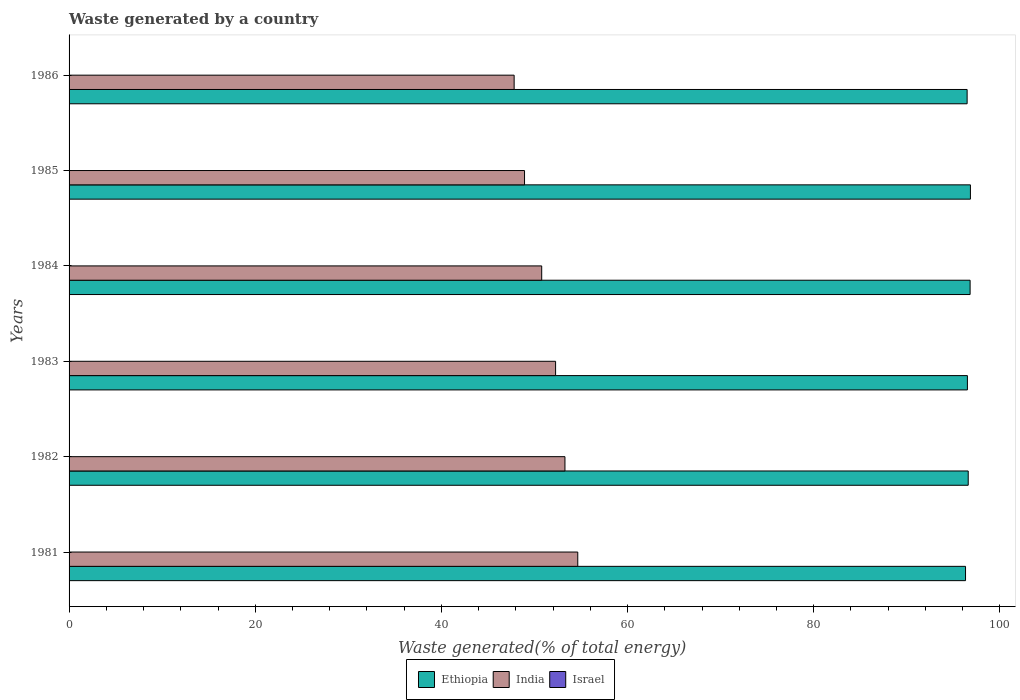How many different coloured bars are there?
Provide a short and direct response. 3. How many groups of bars are there?
Ensure brevity in your answer.  6. Are the number of bars per tick equal to the number of legend labels?
Your answer should be very brief. Yes. Are the number of bars on each tick of the Y-axis equal?
Provide a succinct answer. Yes. How many bars are there on the 5th tick from the bottom?
Your answer should be very brief. 3. What is the label of the 6th group of bars from the top?
Provide a short and direct response. 1981. What is the total waste generated in Israel in 1983?
Provide a succinct answer. 0.03. Across all years, what is the maximum total waste generated in Ethiopia?
Your answer should be compact. 96.84. Across all years, what is the minimum total waste generated in Ethiopia?
Make the answer very short. 96.31. What is the total total waste generated in Israel in the graph?
Your response must be concise. 0.2. What is the difference between the total waste generated in Ethiopia in 1984 and that in 1985?
Give a very brief answer. -0.03. What is the difference between the total waste generated in Ethiopia in 1981 and the total waste generated in Israel in 1983?
Make the answer very short. 96.27. What is the average total waste generated in Ethiopia per year?
Offer a terse response. 96.59. In the year 1983, what is the difference between the total waste generated in Ethiopia and total waste generated in India?
Provide a succinct answer. 44.24. In how many years, is the total waste generated in Ethiopia greater than 52 %?
Keep it short and to the point. 6. What is the ratio of the total waste generated in India in 1984 to that in 1985?
Your answer should be compact. 1.04. Is the difference between the total waste generated in Ethiopia in 1981 and 1983 greater than the difference between the total waste generated in India in 1981 and 1983?
Your answer should be very brief. No. What is the difference between the highest and the second highest total waste generated in Israel?
Your answer should be compact. 0. What is the difference between the highest and the lowest total waste generated in Ethiopia?
Give a very brief answer. 0.53. In how many years, is the total waste generated in India greater than the average total waste generated in India taken over all years?
Keep it short and to the point. 3. Is the sum of the total waste generated in India in 1981 and 1983 greater than the maximum total waste generated in Israel across all years?
Keep it short and to the point. Yes. What does the 1st bar from the bottom in 1986 represents?
Your answer should be very brief. Ethiopia. How many bars are there?
Provide a succinct answer. 18. What is the difference between two consecutive major ticks on the X-axis?
Offer a very short reply. 20. Are the values on the major ticks of X-axis written in scientific E-notation?
Give a very brief answer. No. Does the graph contain any zero values?
Your answer should be very brief. No. How are the legend labels stacked?
Ensure brevity in your answer.  Horizontal. What is the title of the graph?
Provide a succinct answer. Waste generated by a country. What is the label or title of the X-axis?
Ensure brevity in your answer.  Waste generated(% of total energy). What is the label or title of the Y-axis?
Provide a short and direct response. Years. What is the Waste generated(% of total energy) in Ethiopia in 1981?
Offer a very short reply. 96.31. What is the Waste generated(% of total energy) in India in 1981?
Your response must be concise. 54.65. What is the Waste generated(% of total energy) in Israel in 1981?
Offer a very short reply. 0.04. What is the Waste generated(% of total energy) of Ethiopia in 1982?
Give a very brief answer. 96.6. What is the Waste generated(% of total energy) in India in 1982?
Your response must be concise. 53.27. What is the Waste generated(% of total energy) in Israel in 1982?
Keep it short and to the point. 0.03. What is the Waste generated(% of total energy) in Ethiopia in 1983?
Provide a succinct answer. 96.51. What is the Waste generated(% of total energy) of India in 1983?
Your answer should be very brief. 52.27. What is the Waste generated(% of total energy) in Israel in 1983?
Your answer should be compact. 0.03. What is the Waste generated(% of total energy) in Ethiopia in 1984?
Provide a short and direct response. 96.8. What is the Waste generated(% of total energy) of India in 1984?
Give a very brief answer. 50.78. What is the Waste generated(% of total energy) of Israel in 1984?
Offer a very short reply. 0.03. What is the Waste generated(% of total energy) of Ethiopia in 1985?
Offer a very short reply. 96.84. What is the Waste generated(% of total energy) in India in 1985?
Offer a terse response. 48.93. What is the Waste generated(% of total energy) of Israel in 1985?
Offer a terse response. 0.03. What is the Waste generated(% of total energy) in Ethiopia in 1986?
Give a very brief answer. 96.48. What is the Waste generated(% of total energy) of India in 1986?
Offer a terse response. 47.82. What is the Waste generated(% of total energy) in Israel in 1986?
Your answer should be very brief. 0.03. Across all years, what is the maximum Waste generated(% of total energy) in Ethiopia?
Keep it short and to the point. 96.84. Across all years, what is the maximum Waste generated(% of total energy) of India?
Provide a succinct answer. 54.65. Across all years, what is the maximum Waste generated(% of total energy) in Israel?
Offer a terse response. 0.04. Across all years, what is the minimum Waste generated(% of total energy) of Ethiopia?
Make the answer very short. 96.31. Across all years, what is the minimum Waste generated(% of total energy) of India?
Your answer should be compact. 47.82. Across all years, what is the minimum Waste generated(% of total energy) in Israel?
Keep it short and to the point. 0.03. What is the total Waste generated(% of total energy) in Ethiopia in the graph?
Keep it short and to the point. 579.54. What is the total Waste generated(% of total energy) in India in the graph?
Ensure brevity in your answer.  307.72. What is the total Waste generated(% of total energy) in Israel in the graph?
Your answer should be compact. 0.2. What is the difference between the Waste generated(% of total energy) of Ethiopia in 1981 and that in 1982?
Make the answer very short. -0.29. What is the difference between the Waste generated(% of total energy) of India in 1981 and that in 1982?
Keep it short and to the point. 1.38. What is the difference between the Waste generated(% of total energy) in Israel in 1981 and that in 1982?
Make the answer very short. 0. What is the difference between the Waste generated(% of total energy) of Ethiopia in 1981 and that in 1983?
Make the answer very short. -0.2. What is the difference between the Waste generated(% of total energy) in India in 1981 and that in 1983?
Offer a terse response. 2.38. What is the difference between the Waste generated(% of total energy) in Ethiopia in 1981 and that in 1984?
Ensure brevity in your answer.  -0.49. What is the difference between the Waste generated(% of total energy) of India in 1981 and that in 1984?
Offer a terse response. 3.87. What is the difference between the Waste generated(% of total energy) of Israel in 1981 and that in 1984?
Your answer should be compact. 0. What is the difference between the Waste generated(% of total energy) of Ethiopia in 1981 and that in 1985?
Your response must be concise. -0.53. What is the difference between the Waste generated(% of total energy) of India in 1981 and that in 1985?
Provide a short and direct response. 5.72. What is the difference between the Waste generated(% of total energy) in Israel in 1981 and that in 1985?
Provide a short and direct response. 0. What is the difference between the Waste generated(% of total energy) of Ethiopia in 1981 and that in 1986?
Give a very brief answer. -0.17. What is the difference between the Waste generated(% of total energy) in India in 1981 and that in 1986?
Ensure brevity in your answer.  6.83. What is the difference between the Waste generated(% of total energy) in Israel in 1981 and that in 1986?
Offer a very short reply. 0.01. What is the difference between the Waste generated(% of total energy) in Ethiopia in 1982 and that in 1983?
Offer a very short reply. 0.09. What is the difference between the Waste generated(% of total energy) of India in 1982 and that in 1983?
Provide a short and direct response. 1.01. What is the difference between the Waste generated(% of total energy) of Israel in 1982 and that in 1983?
Your answer should be compact. -0. What is the difference between the Waste generated(% of total energy) in Ethiopia in 1982 and that in 1984?
Offer a terse response. -0.2. What is the difference between the Waste generated(% of total energy) in India in 1982 and that in 1984?
Your response must be concise. 2.5. What is the difference between the Waste generated(% of total energy) of Israel in 1982 and that in 1984?
Offer a very short reply. -0. What is the difference between the Waste generated(% of total energy) in Ethiopia in 1982 and that in 1985?
Make the answer very short. -0.24. What is the difference between the Waste generated(% of total energy) of India in 1982 and that in 1985?
Give a very brief answer. 4.34. What is the difference between the Waste generated(% of total energy) in Israel in 1982 and that in 1985?
Ensure brevity in your answer.  -0. What is the difference between the Waste generated(% of total energy) of Ethiopia in 1982 and that in 1986?
Make the answer very short. 0.12. What is the difference between the Waste generated(% of total energy) of India in 1982 and that in 1986?
Your answer should be very brief. 5.46. What is the difference between the Waste generated(% of total energy) of Israel in 1982 and that in 1986?
Your answer should be very brief. 0. What is the difference between the Waste generated(% of total energy) in Ethiopia in 1983 and that in 1984?
Keep it short and to the point. -0.29. What is the difference between the Waste generated(% of total energy) in India in 1983 and that in 1984?
Your response must be concise. 1.49. What is the difference between the Waste generated(% of total energy) of Israel in 1983 and that in 1984?
Offer a very short reply. 0. What is the difference between the Waste generated(% of total energy) of Ethiopia in 1983 and that in 1985?
Offer a terse response. -0.32. What is the difference between the Waste generated(% of total energy) in India in 1983 and that in 1985?
Provide a short and direct response. 3.34. What is the difference between the Waste generated(% of total energy) in Israel in 1983 and that in 1985?
Keep it short and to the point. 0. What is the difference between the Waste generated(% of total energy) of Ethiopia in 1983 and that in 1986?
Give a very brief answer. 0.03. What is the difference between the Waste generated(% of total energy) in India in 1983 and that in 1986?
Make the answer very short. 4.45. What is the difference between the Waste generated(% of total energy) of Israel in 1983 and that in 1986?
Offer a very short reply. 0.01. What is the difference between the Waste generated(% of total energy) of Ethiopia in 1984 and that in 1985?
Provide a short and direct response. -0.03. What is the difference between the Waste generated(% of total energy) in India in 1984 and that in 1985?
Give a very brief answer. 1.85. What is the difference between the Waste generated(% of total energy) in Israel in 1984 and that in 1985?
Keep it short and to the point. -0. What is the difference between the Waste generated(% of total energy) in Ethiopia in 1984 and that in 1986?
Keep it short and to the point. 0.32. What is the difference between the Waste generated(% of total energy) of India in 1984 and that in 1986?
Provide a short and direct response. 2.96. What is the difference between the Waste generated(% of total energy) of Israel in 1984 and that in 1986?
Provide a succinct answer. 0.01. What is the difference between the Waste generated(% of total energy) in Ethiopia in 1985 and that in 1986?
Offer a terse response. 0.35. What is the difference between the Waste generated(% of total energy) of India in 1985 and that in 1986?
Offer a terse response. 1.12. What is the difference between the Waste generated(% of total energy) of Israel in 1985 and that in 1986?
Your response must be concise. 0.01. What is the difference between the Waste generated(% of total energy) of Ethiopia in 1981 and the Waste generated(% of total energy) of India in 1982?
Your answer should be compact. 43.03. What is the difference between the Waste generated(% of total energy) of Ethiopia in 1981 and the Waste generated(% of total energy) of Israel in 1982?
Ensure brevity in your answer.  96.28. What is the difference between the Waste generated(% of total energy) in India in 1981 and the Waste generated(% of total energy) in Israel in 1982?
Offer a very short reply. 54.62. What is the difference between the Waste generated(% of total energy) in Ethiopia in 1981 and the Waste generated(% of total energy) in India in 1983?
Your answer should be compact. 44.04. What is the difference between the Waste generated(% of total energy) of Ethiopia in 1981 and the Waste generated(% of total energy) of Israel in 1983?
Give a very brief answer. 96.27. What is the difference between the Waste generated(% of total energy) in India in 1981 and the Waste generated(% of total energy) in Israel in 1983?
Give a very brief answer. 54.62. What is the difference between the Waste generated(% of total energy) in Ethiopia in 1981 and the Waste generated(% of total energy) in India in 1984?
Provide a short and direct response. 45.53. What is the difference between the Waste generated(% of total energy) in Ethiopia in 1981 and the Waste generated(% of total energy) in Israel in 1984?
Keep it short and to the point. 96.28. What is the difference between the Waste generated(% of total energy) of India in 1981 and the Waste generated(% of total energy) of Israel in 1984?
Provide a succinct answer. 54.62. What is the difference between the Waste generated(% of total energy) in Ethiopia in 1981 and the Waste generated(% of total energy) in India in 1985?
Make the answer very short. 47.38. What is the difference between the Waste generated(% of total energy) of Ethiopia in 1981 and the Waste generated(% of total energy) of Israel in 1985?
Provide a succinct answer. 96.28. What is the difference between the Waste generated(% of total energy) of India in 1981 and the Waste generated(% of total energy) of Israel in 1985?
Provide a succinct answer. 54.62. What is the difference between the Waste generated(% of total energy) in Ethiopia in 1981 and the Waste generated(% of total energy) in India in 1986?
Ensure brevity in your answer.  48.49. What is the difference between the Waste generated(% of total energy) in Ethiopia in 1981 and the Waste generated(% of total energy) in Israel in 1986?
Keep it short and to the point. 96.28. What is the difference between the Waste generated(% of total energy) in India in 1981 and the Waste generated(% of total energy) in Israel in 1986?
Your answer should be very brief. 54.62. What is the difference between the Waste generated(% of total energy) of Ethiopia in 1982 and the Waste generated(% of total energy) of India in 1983?
Make the answer very short. 44.33. What is the difference between the Waste generated(% of total energy) in Ethiopia in 1982 and the Waste generated(% of total energy) in Israel in 1983?
Offer a terse response. 96.56. What is the difference between the Waste generated(% of total energy) in India in 1982 and the Waste generated(% of total energy) in Israel in 1983?
Your answer should be very brief. 53.24. What is the difference between the Waste generated(% of total energy) of Ethiopia in 1982 and the Waste generated(% of total energy) of India in 1984?
Offer a very short reply. 45.82. What is the difference between the Waste generated(% of total energy) in Ethiopia in 1982 and the Waste generated(% of total energy) in Israel in 1984?
Your answer should be compact. 96.56. What is the difference between the Waste generated(% of total energy) of India in 1982 and the Waste generated(% of total energy) of Israel in 1984?
Your answer should be very brief. 53.24. What is the difference between the Waste generated(% of total energy) in Ethiopia in 1982 and the Waste generated(% of total energy) in India in 1985?
Offer a terse response. 47.67. What is the difference between the Waste generated(% of total energy) in Ethiopia in 1982 and the Waste generated(% of total energy) in Israel in 1985?
Offer a terse response. 96.56. What is the difference between the Waste generated(% of total energy) of India in 1982 and the Waste generated(% of total energy) of Israel in 1985?
Make the answer very short. 53.24. What is the difference between the Waste generated(% of total energy) of Ethiopia in 1982 and the Waste generated(% of total energy) of India in 1986?
Your response must be concise. 48.78. What is the difference between the Waste generated(% of total energy) in Ethiopia in 1982 and the Waste generated(% of total energy) in Israel in 1986?
Offer a terse response. 96.57. What is the difference between the Waste generated(% of total energy) in India in 1982 and the Waste generated(% of total energy) in Israel in 1986?
Give a very brief answer. 53.25. What is the difference between the Waste generated(% of total energy) in Ethiopia in 1983 and the Waste generated(% of total energy) in India in 1984?
Keep it short and to the point. 45.74. What is the difference between the Waste generated(% of total energy) of Ethiopia in 1983 and the Waste generated(% of total energy) of Israel in 1984?
Your answer should be compact. 96.48. What is the difference between the Waste generated(% of total energy) in India in 1983 and the Waste generated(% of total energy) in Israel in 1984?
Ensure brevity in your answer.  52.24. What is the difference between the Waste generated(% of total energy) of Ethiopia in 1983 and the Waste generated(% of total energy) of India in 1985?
Make the answer very short. 47.58. What is the difference between the Waste generated(% of total energy) in Ethiopia in 1983 and the Waste generated(% of total energy) in Israel in 1985?
Ensure brevity in your answer.  96.48. What is the difference between the Waste generated(% of total energy) in India in 1983 and the Waste generated(% of total energy) in Israel in 1985?
Provide a succinct answer. 52.24. What is the difference between the Waste generated(% of total energy) in Ethiopia in 1983 and the Waste generated(% of total energy) in India in 1986?
Offer a very short reply. 48.7. What is the difference between the Waste generated(% of total energy) of Ethiopia in 1983 and the Waste generated(% of total energy) of Israel in 1986?
Keep it short and to the point. 96.48. What is the difference between the Waste generated(% of total energy) of India in 1983 and the Waste generated(% of total energy) of Israel in 1986?
Offer a very short reply. 52.24. What is the difference between the Waste generated(% of total energy) in Ethiopia in 1984 and the Waste generated(% of total energy) in India in 1985?
Your answer should be very brief. 47.87. What is the difference between the Waste generated(% of total energy) in Ethiopia in 1984 and the Waste generated(% of total energy) in Israel in 1985?
Your response must be concise. 96.77. What is the difference between the Waste generated(% of total energy) of India in 1984 and the Waste generated(% of total energy) of Israel in 1985?
Your response must be concise. 50.74. What is the difference between the Waste generated(% of total energy) in Ethiopia in 1984 and the Waste generated(% of total energy) in India in 1986?
Your answer should be compact. 48.99. What is the difference between the Waste generated(% of total energy) in Ethiopia in 1984 and the Waste generated(% of total energy) in Israel in 1986?
Provide a short and direct response. 96.77. What is the difference between the Waste generated(% of total energy) in India in 1984 and the Waste generated(% of total energy) in Israel in 1986?
Ensure brevity in your answer.  50.75. What is the difference between the Waste generated(% of total energy) of Ethiopia in 1985 and the Waste generated(% of total energy) of India in 1986?
Keep it short and to the point. 49.02. What is the difference between the Waste generated(% of total energy) in Ethiopia in 1985 and the Waste generated(% of total energy) in Israel in 1986?
Ensure brevity in your answer.  96.81. What is the difference between the Waste generated(% of total energy) in India in 1985 and the Waste generated(% of total energy) in Israel in 1986?
Provide a short and direct response. 48.9. What is the average Waste generated(% of total energy) of Ethiopia per year?
Keep it short and to the point. 96.59. What is the average Waste generated(% of total energy) of India per year?
Provide a succinct answer. 51.29. What is the average Waste generated(% of total energy) of Israel per year?
Offer a terse response. 0.03. In the year 1981, what is the difference between the Waste generated(% of total energy) of Ethiopia and Waste generated(% of total energy) of India?
Make the answer very short. 41.66. In the year 1981, what is the difference between the Waste generated(% of total energy) of Ethiopia and Waste generated(% of total energy) of Israel?
Give a very brief answer. 96.27. In the year 1981, what is the difference between the Waste generated(% of total energy) in India and Waste generated(% of total energy) in Israel?
Offer a terse response. 54.62. In the year 1982, what is the difference between the Waste generated(% of total energy) in Ethiopia and Waste generated(% of total energy) in India?
Provide a succinct answer. 43.32. In the year 1982, what is the difference between the Waste generated(% of total energy) of Ethiopia and Waste generated(% of total energy) of Israel?
Offer a very short reply. 96.57. In the year 1982, what is the difference between the Waste generated(% of total energy) in India and Waste generated(% of total energy) in Israel?
Offer a terse response. 53.24. In the year 1983, what is the difference between the Waste generated(% of total energy) in Ethiopia and Waste generated(% of total energy) in India?
Keep it short and to the point. 44.24. In the year 1983, what is the difference between the Waste generated(% of total energy) in Ethiopia and Waste generated(% of total energy) in Israel?
Offer a terse response. 96.48. In the year 1983, what is the difference between the Waste generated(% of total energy) in India and Waste generated(% of total energy) in Israel?
Provide a short and direct response. 52.23. In the year 1984, what is the difference between the Waste generated(% of total energy) in Ethiopia and Waste generated(% of total energy) in India?
Ensure brevity in your answer.  46.03. In the year 1984, what is the difference between the Waste generated(% of total energy) in Ethiopia and Waste generated(% of total energy) in Israel?
Your answer should be very brief. 96.77. In the year 1984, what is the difference between the Waste generated(% of total energy) of India and Waste generated(% of total energy) of Israel?
Offer a very short reply. 50.74. In the year 1985, what is the difference between the Waste generated(% of total energy) in Ethiopia and Waste generated(% of total energy) in India?
Give a very brief answer. 47.9. In the year 1985, what is the difference between the Waste generated(% of total energy) in Ethiopia and Waste generated(% of total energy) in Israel?
Give a very brief answer. 96.8. In the year 1985, what is the difference between the Waste generated(% of total energy) in India and Waste generated(% of total energy) in Israel?
Keep it short and to the point. 48.9. In the year 1986, what is the difference between the Waste generated(% of total energy) in Ethiopia and Waste generated(% of total energy) in India?
Your answer should be very brief. 48.67. In the year 1986, what is the difference between the Waste generated(% of total energy) in Ethiopia and Waste generated(% of total energy) in Israel?
Keep it short and to the point. 96.45. In the year 1986, what is the difference between the Waste generated(% of total energy) in India and Waste generated(% of total energy) in Israel?
Ensure brevity in your answer.  47.79. What is the ratio of the Waste generated(% of total energy) of Ethiopia in 1981 to that in 1982?
Your answer should be very brief. 1. What is the ratio of the Waste generated(% of total energy) in India in 1981 to that in 1982?
Provide a short and direct response. 1.03. What is the ratio of the Waste generated(% of total energy) of Israel in 1981 to that in 1982?
Your response must be concise. 1.08. What is the ratio of the Waste generated(% of total energy) in Ethiopia in 1981 to that in 1983?
Provide a short and direct response. 1. What is the ratio of the Waste generated(% of total energy) in India in 1981 to that in 1983?
Keep it short and to the point. 1.05. What is the ratio of the Waste generated(% of total energy) in Israel in 1981 to that in 1983?
Provide a succinct answer. 1.01. What is the ratio of the Waste generated(% of total energy) of Ethiopia in 1981 to that in 1984?
Ensure brevity in your answer.  0.99. What is the ratio of the Waste generated(% of total energy) of India in 1981 to that in 1984?
Keep it short and to the point. 1.08. What is the ratio of the Waste generated(% of total energy) of Israel in 1981 to that in 1984?
Your answer should be compact. 1.04. What is the ratio of the Waste generated(% of total energy) in Ethiopia in 1981 to that in 1985?
Offer a terse response. 0.99. What is the ratio of the Waste generated(% of total energy) of India in 1981 to that in 1985?
Give a very brief answer. 1.12. What is the ratio of the Waste generated(% of total energy) in Israel in 1981 to that in 1985?
Ensure brevity in your answer.  1.04. What is the ratio of the Waste generated(% of total energy) in Ethiopia in 1981 to that in 1986?
Offer a terse response. 1. What is the ratio of the Waste generated(% of total energy) of India in 1981 to that in 1986?
Keep it short and to the point. 1.14. What is the ratio of the Waste generated(% of total energy) in Israel in 1981 to that in 1986?
Ensure brevity in your answer.  1.24. What is the ratio of the Waste generated(% of total energy) of India in 1982 to that in 1983?
Offer a terse response. 1.02. What is the ratio of the Waste generated(% of total energy) of Israel in 1982 to that in 1983?
Your response must be concise. 0.93. What is the ratio of the Waste generated(% of total energy) in India in 1982 to that in 1984?
Make the answer very short. 1.05. What is the ratio of the Waste generated(% of total energy) in Israel in 1982 to that in 1984?
Your response must be concise. 0.96. What is the ratio of the Waste generated(% of total energy) in India in 1982 to that in 1985?
Provide a short and direct response. 1.09. What is the ratio of the Waste generated(% of total energy) in Israel in 1982 to that in 1985?
Offer a very short reply. 0.96. What is the ratio of the Waste generated(% of total energy) in Ethiopia in 1982 to that in 1986?
Give a very brief answer. 1. What is the ratio of the Waste generated(% of total energy) in India in 1982 to that in 1986?
Your response must be concise. 1.11. What is the ratio of the Waste generated(% of total energy) of Israel in 1982 to that in 1986?
Give a very brief answer. 1.14. What is the ratio of the Waste generated(% of total energy) of Ethiopia in 1983 to that in 1984?
Make the answer very short. 1. What is the ratio of the Waste generated(% of total energy) of India in 1983 to that in 1984?
Keep it short and to the point. 1.03. What is the ratio of the Waste generated(% of total energy) of Israel in 1983 to that in 1984?
Ensure brevity in your answer.  1.03. What is the ratio of the Waste generated(% of total energy) of Ethiopia in 1983 to that in 1985?
Your response must be concise. 1. What is the ratio of the Waste generated(% of total energy) of India in 1983 to that in 1985?
Your answer should be compact. 1.07. What is the ratio of the Waste generated(% of total energy) of Israel in 1983 to that in 1985?
Your answer should be very brief. 1.03. What is the ratio of the Waste generated(% of total energy) in India in 1983 to that in 1986?
Provide a succinct answer. 1.09. What is the ratio of the Waste generated(% of total energy) of Israel in 1983 to that in 1986?
Ensure brevity in your answer.  1.23. What is the ratio of the Waste generated(% of total energy) of Ethiopia in 1984 to that in 1985?
Provide a succinct answer. 1. What is the ratio of the Waste generated(% of total energy) in India in 1984 to that in 1985?
Offer a very short reply. 1.04. What is the ratio of the Waste generated(% of total energy) of Israel in 1984 to that in 1985?
Your answer should be compact. 1. What is the ratio of the Waste generated(% of total energy) of India in 1984 to that in 1986?
Offer a very short reply. 1.06. What is the ratio of the Waste generated(% of total energy) of Israel in 1984 to that in 1986?
Give a very brief answer. 1.19. What is the ratio of the Waste generated(% of total energy) of India in 1985 to that in 1986?
Offer a very short reply. 1.02. What is the ratio of the Waste generated(% of total energy) of Israel in 1985 to that in 1986?
Provide a succinct answer. 1.19. What is the difference between the highest and the second highest Waste generated(% of total energy) in Ethiopia?
Keep it short and to the point. 0.03. What is the difference between the highest and the second highest Waste generated(% of total energy) of India?
Make the answer very short. 1.38. What is the difference between the highest and the lowest Waste generated(% of total energy) in Ethiopia?
Make the answer very short. 0.53. What is the difference between the highest and the lowest Waste generated(% of total energy) in India?
Your answer should be very brief. 6.83. What is the difference between the highest and the lowest Waste generated(% of total energy) in Israel?
Offer a terse response. 0.01. 